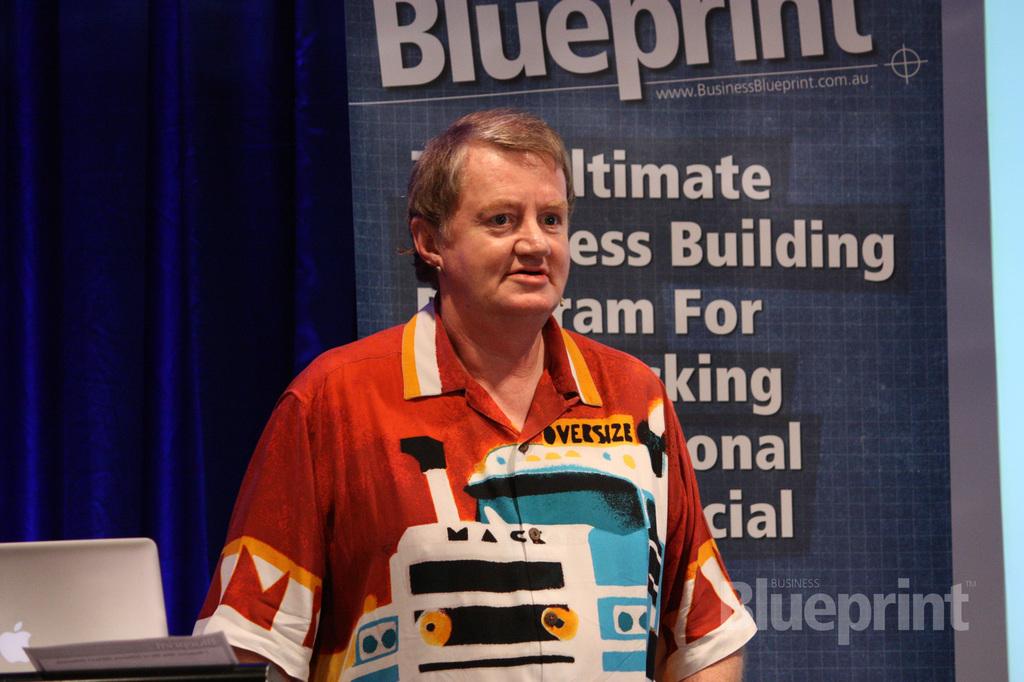What is the website on the poster?
Provide a succinct answer. Www.businessblueprint.com.au. What brand of truck is on the man's shirt?
Your answer should be very brief. Mack. 